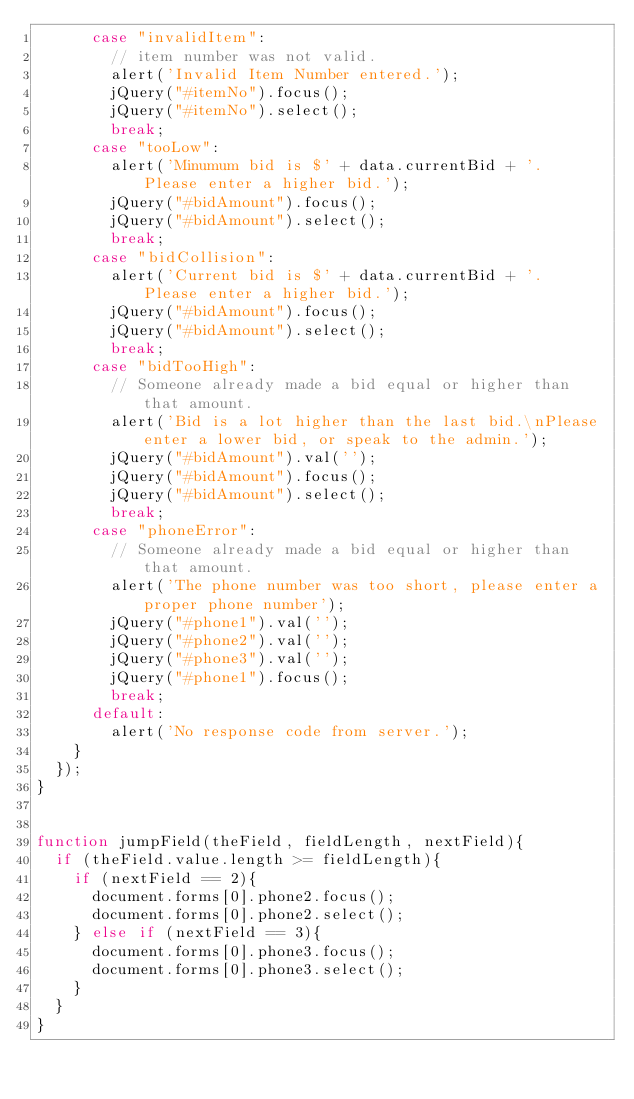<code> <loc_0><loc_0><loc_500><loc_500><_JavaScript_>			case "invalidItem":
				// item number was not valid.
				alert('Invalid Item Number entered.');
				jQuery("#itemNo").focus();
				jQuery("#itemNo").select();
				break;
			case "tooLow":
				alert('Minumum bid is $' + data.currentBid + '.  Please enter a higher bid.');
				jQuery("#bidAmount").focus();
				jQuery("#bidAmount").select();
				break;
			case "bidCollision":
				alert('Current bid is $' + data.currentBid + '.  Please enter a higher bid.');
				jQuery("#bidAmount").focus();
				jQuery("#bidAmount").select();
				break;
			case "bidTooHigh":
				// Someone already made a bid equal or higher than that amount.
				alert('Bid is a lot higher than the last bid.\nPlease enter a lower bid, or speak to the admin.');
				jQuery("#bidAmount").val('');
				jQuery("#bidAmount").focus();
				jQuery("#bidAmount").select();
				break;
			case "phoneError":
				// Someone already made a bid equal or higher than that amount.
				alert('The phone number was too short, please enter a proper phone number');
				jQuery("#phone1").val('');
				jQuery("#phone2").val('');
				jQuery("#phone3").val('');
				jQuery("#phone1").focus();
				break;
			default:
				alert('No response code from server.');
		}
	});
}


function jumpField(theField, fieldLength, nextField){
	if (theField.value.length >= fieldLength){
		if (nextField == 2){
			document.forms[0].phone2.focus();
			document.forms[0].phone2.select();
		} else if (nextField == 3){
			document.forms[0].phone3.focus();
			document.forms[0].phone3.select();
		}
	}
}
</code> 